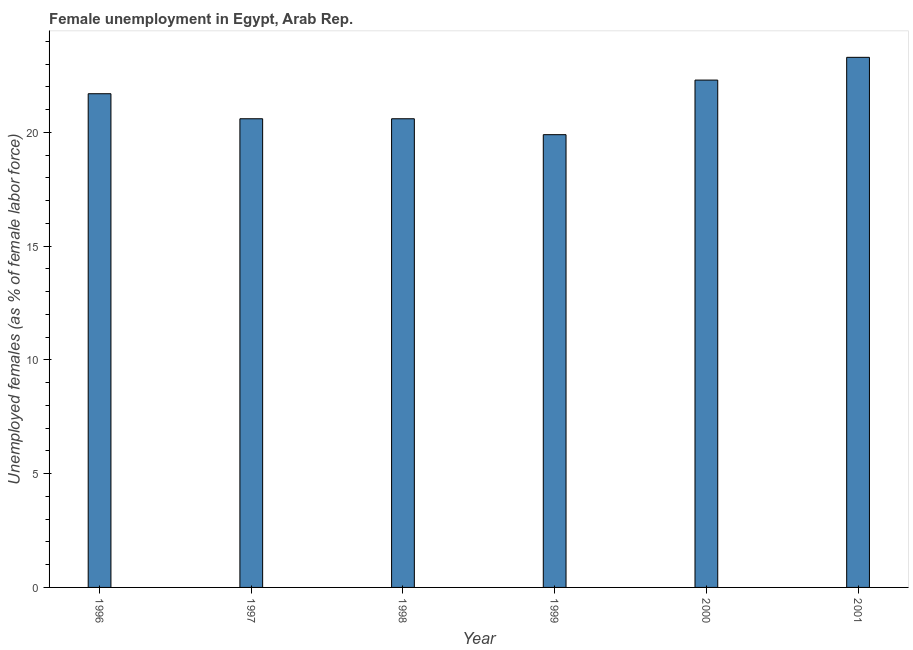Does the graph contain any zero values?
Provide a succinct answer. No. Does the graph contain grids?
Ensure brevity in your answer.  No. What is the title of the graph?
Provide a succinct answer. Female unemployment in Egypt, Arab Rep. What is the label or title of the Y-axis?
Keep it short and to the point. Unemployed females (as % of female labor force). What is the unemployed females population in 1997?
Offer a terse response. 20.6. Across all years, what is the maximum unemployed females population?
Offer a terse response. 23.3. Across all years, what is the minimum unemployed females population?
Offer a very short reply. 19.9. In which year was the unemployed females population minimum?
Ensure brevity in your answer.  1999. What is the sum of the unemployed females population?
Keep it short and to the point. 128.4. What is the average unemployed females population per year?
Give a very brief answer. 21.4. What is the median unemployed females population?
Your answer should be compact. 21.15. What is the ratio of the unemployed females population in 1999 to that in 2001?
Keep it short and to the point. 0.85. Is the difference between the unemployed females population in 1997 and 1998 greater than the difference between any two years?
Give a very brief answer. No. What is the difference between the highest and the lowest unemployed females population?
Keep it short and to the point. 3.4. How many years are there in the graph?
Give a very brief answer. 6. What is the Unemployed females (as % of female labor force) of 1996?
Provide a short and direct response. 21.7. What is the Unemployed females (as % of female labor force) in 1997?
Offer a terse response. 20.6. What is the Unemployed females (as % of female labor force) of 1998?
Make the answer very short. 20.6. What is the Unemployed females (as % of female labor force) of 1999?
Provide a succinct answer. 19.9. What is the Unemployed females (as % of female labor force) in 2000?
Your answer should be compact. 22.3. What is the Unemployed females (as % of female labor force) of 2001?
Keep it short and to the point. 23.3. What is the difference between the Unemployed females (as % of female labor force) in 1996 and 2001?
Ensure brevity in your answer.  -1.6. What is the difference between the Unemployed females (as % of female labor force) in 1997 and 1999?
Give a very brief answer. 0.7. What is the difference between the Unemployed females (as % of female labor force) in 1997 and 2000?
Your answer should be compact. -1.7. What is the difference between the Unemployed females (as % of female labor force) in 1998 and 1999?
Make the answer very short. 0.7. What is the difference between the Unemployed females (as % of female labor force) in 1999 and 2000?
Your response must be concise. -2.4. What is the difference between the Unemployed females (as % of female labor force) in 1999 and 2001?
Your answer should be very brief. -3.4. What is the ratio of the Unemployed females (as % of female labor force) in 1996 to that in 1997?
Make the answer very short. 1.05. What is the ratio of the Unemployed females (as % of female labor force) in 1996 to that in 1998?
Keep it short and to the point. 1.05. What is the ratio of the Unemployed females (as % of female labor force) in 1996 to that in 1999?
Keep it short and to the point. 1.09. What is the ratio of the Unemployed females (as % of female labor force) in 1997 to that in 1998?
Offer a terse response. 1. What is the ratio of the Unemployed females (as % of female labor force) in 1997 to that in 1999?
Make the answer very short. 1.03. What is the ratio of the Unemployed females (as % of female labor force) in 1997 to that in 2000?
Offer a very short reply. 0.92. What is the ratio of the Unemployed females (as % of female labor force) in 1997 to that in 2001?
Ensure brevity in your answer.  0.88. What is the ratio of the Unemployed females (as % of female labor force) in 1998 to that in 1999?
Your answer should be compact. 1.03. What is the ratio of the Unemployed females (as % of female labor force) in 1998 to that in 2000?
Offer a terse response. 0.92. What is the ratio of the Unemployed females (as % of female labor force) in 1998 to that in 2001?
Provide a succinct answer. 0.88. What is the ratio of the Unemployed females (as % of female labor force) in 1999 to that in 2000?
Ensure brevity in your answer.  0.89. What is the ratio of the Unemployed females (as % of female labor force) in 1999 to that in 2001?
Offer a terse response. 0.85. What is the ratio of the Unemployed females (as % of female labor force) in 2000 to that in 2001?
Offer a very short reply. 0.96. 